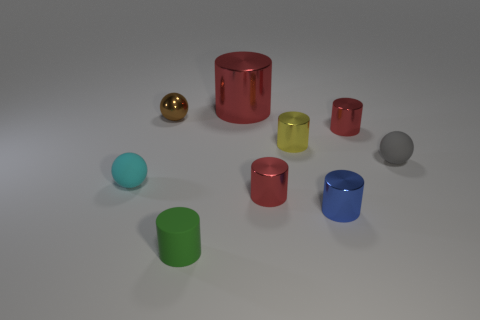Subtract all red cylinders. How many were subtracted if there are1red cylinders left? 2 Subtract all brown blocks. How many red cylinders are left? 3 Subtract all tiny green rubber cylinders. How many cylinders are left? 5 Subtract all yellow cylinders. How many cylinders are left? 5 Subtract 4 cylinders. How many cylinders are left? 2 Subtract all cyan cylinders. Subtract all green blocks. How many cylinders are left? 6 Add 1 gray rubber balls. How many objects exist? 10 Subtract all balls. How many objects are left? 6 Add 3 large things. How many large things are left? 4 Add 3 cyan matte objects. How many cyan matte objects exist? 4 